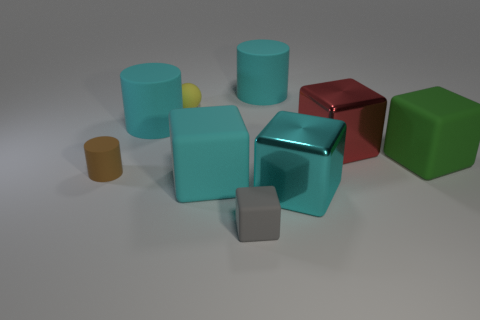Subtract all big cylinders. How many cylinders are left? 1 Subtract all yellow spheres. How many cyan cylinders are left? 2 Add 1 big brown rubber blocks. How many objects exist? 10 Subtract all cyan cubes. How many cubes are left? 3 Subtract 2 cylinders. How many cylinders are left? 1 Subtract all spheres. How many objects are left? 8 Subtract 0 blue cubes. How many objects are left? 9 Subtract all purple blocks. Subtract all gray cylinders. How many blocks are left? 5 Subtract all yellow rubber objects. Subtract all tiny gray things. How many objects are left? 7 Add 6 large green matte cubes. How many large green matte cubes are left? 7 